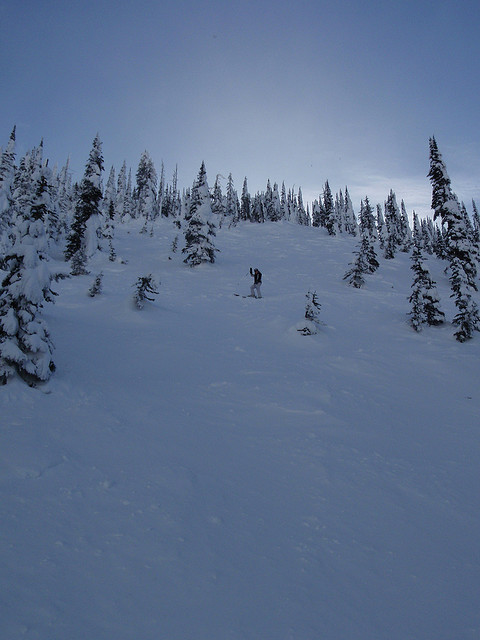Is there a person skiing or snowboarding in the image?
 There is a person snowboarding in the image. What is the condition of the slope in the image? The slope in the image is covered in snow, with trees surrounding the area. What kind of trees can be seen in the image? The image features pine trees and fir trees draped in snow. What details can be observed about the mountain in the image? The mountain in the image is snow-covered, creating a beautiful and serene winter landscape with snow-draped pine and fir trees. It appears to be a popular location for winter sports enthusiasts, as evidenced by the snowboarder navigating the slope and the group of people riding down the snow-covered ski slope. Can you discuss the potential challenges posed by the snow-covered terrain for winter sports enthusiasts like snowboarders and skiers? Snow-covered terrain can present various challenges for winter sports enthusiasts, such as snowboarders and skiers, while also offering a unique and exhilarating experience. Some of the potential challenges encountered by snowboarders and skiers on a snow-covered slope with trees include:

1. Visibility: Poor visibility due to falling snow, fog, or low light conditions can make it harder for winter sports enthusiasts to see obstacles, other people, and changes in the terrain. Proper goggles and awareness of the surroundings are crucial for safety in such conditions.

2. Tree well hazards: When snow accumulates around a tree's base, it creates a depression known as a tree well. If a snowboarder or skier gets too close to a tree and falls into a tree well, it can lead to a dangerous situation where the person might be unable to climb out or breathe due to the snow. Staying on marked trails and being cautious around trees can help mitigate this risk.

3. Uneven terrain: Snow can conceal uneven terrain, such as bumps, dips, and rocks. Navigating such terrain requires skill, experience, and attentiveness, as sudden changes can lead to falls or injuries.

4. Collision risks: Skiing or snowboarding through tree-filled areas increases the risk of colliding with a tree or other obstacles. Snowboarders and skiers need to maintain control and be aware of their surroundings to avoid collisions.

5. Avalanche risk: Snow-covered slopes, particularly those in mountainous areas, can sometimes pose a risk of avalanches triggered by shifting snow layers or human activity. Winter sports enthusiasts should be educated on avalanche safety, check local avalanche forecasts, and carry appropriate safety equipment if venturing into areas prone to avalanches.

Despite these challenges, snowboarders and skiers often find themselves drawn to the thrill of navigating snow-covered slopes and tree-filled areas. By being prepared and cautious, enthusiasts can minimize the risks and fully enjoy the unique beauty and adrenaline that winter sports offer. 